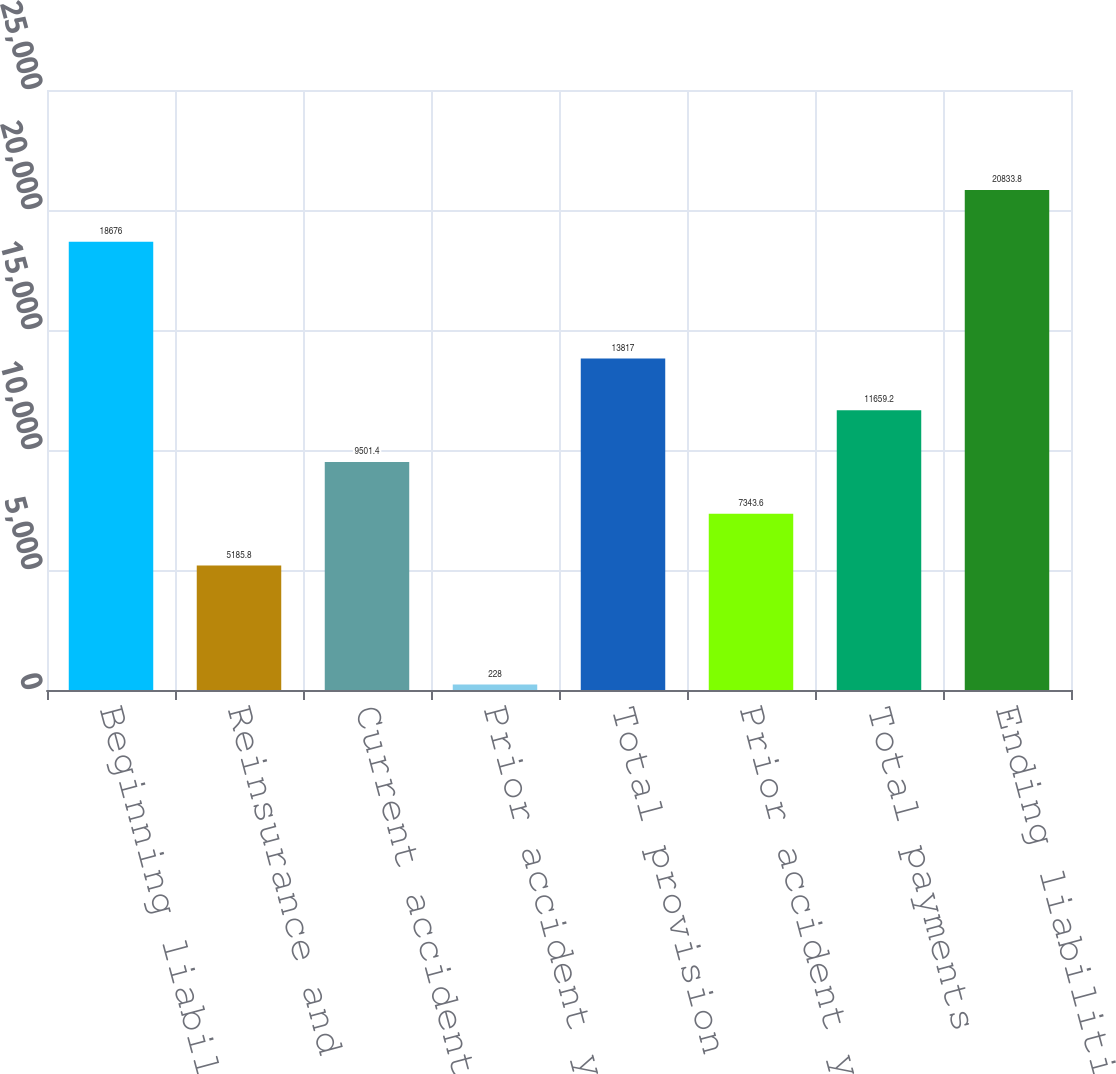Convert chart to OTSL. <chart><loc_0><loc_0><loc_500><loc_500><bar_chart><fcel>Beginning liabilities for<fcel>Reinsurance and other<fcel>Current accident year<fcel>Prior accident year<fcel>Total provision for unpaid<fcel>Prior accident years<fcel>Total payments<fcel>Ending liabilities for unpaid<nl><fcel>18676<fcel>5185.8<fcel>9501.4<fcel>228<fcel>13817<fcel>7343.6<fcel>11659.2<fcel>20833.8<nl></chart> 